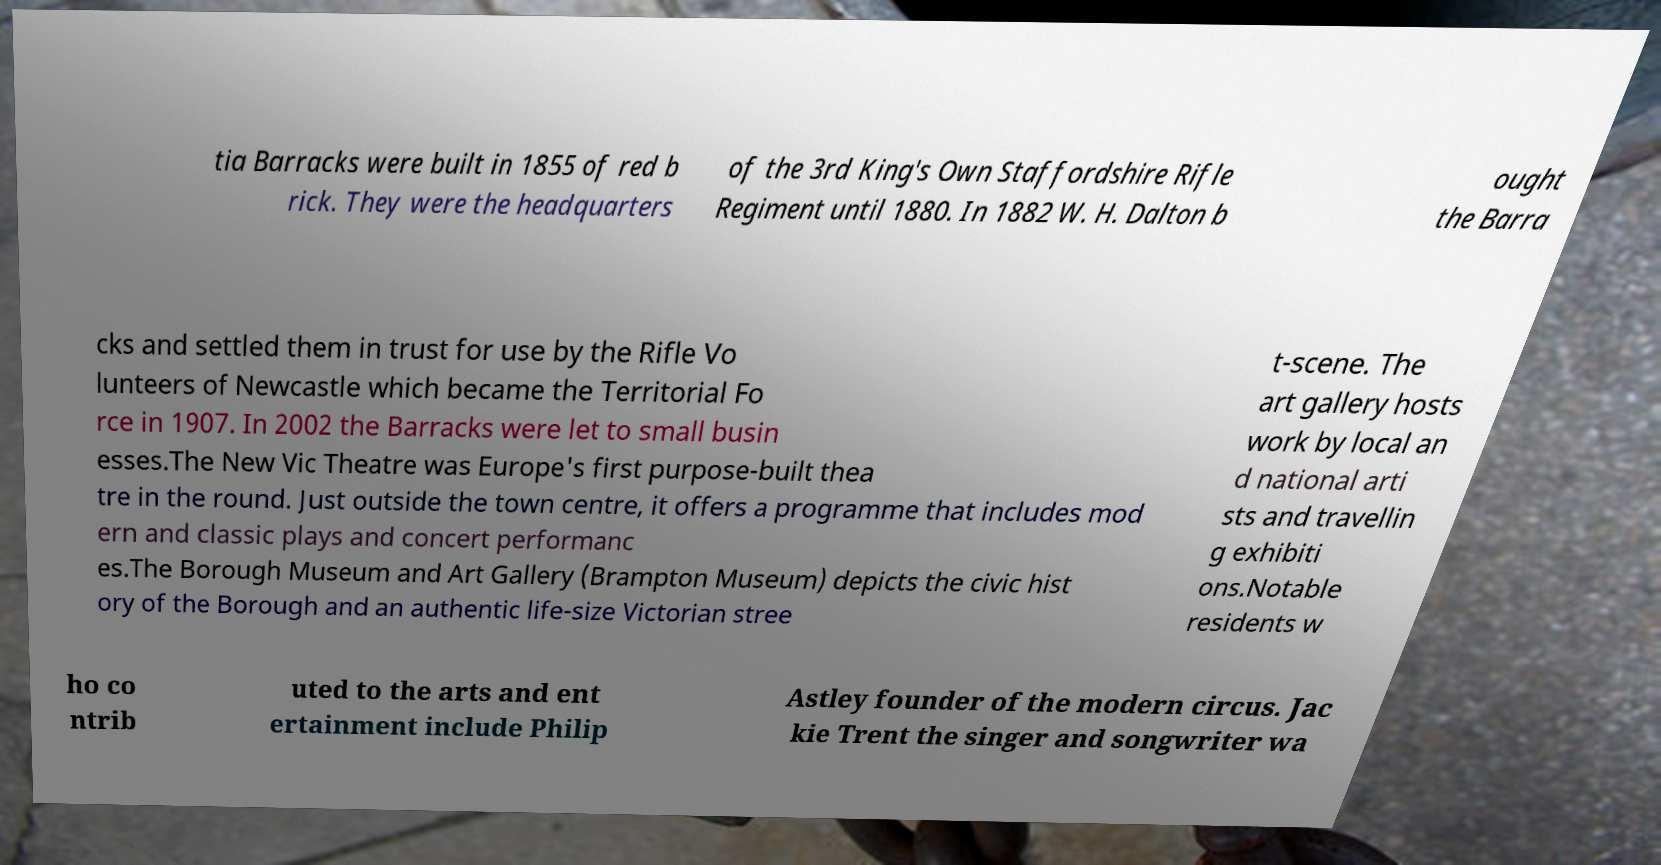Could you assist in decoding the text presented in this image and type it out clearly? tia Barracks were built in 1855 of red b rick. They were the headquarters of the 3rd King's Own Staffordshire Rifle Regiment until 1880. In 1882 W. H. Dalton b ought the Barra cks and settled them in trust for use by the Rifle Vo lunteers of Newcastle which became the Territorial Fo rce in 1907. In 2002 the Barracks were let to small busin esses.The New Vic Theatre was Europe's first purpose-built thea tre in the round. Just outside the town centre, it offers a programme that includes mod ern and classic plays and concert performanc es.The Borough Museum and Art Gallery (Brampton Museum) depicts the civic hist ory of the Borough and an authentic life-size Victorian stree t-scene. The art gallery hosts work by local an d national arti sts and travellin g exhibiti ons.Notable residents w ho co ntrib uted to the arts and ent ertainment include Philip Astley founder of the modern circus. Jac kie Trent the singer and songwriter wa 